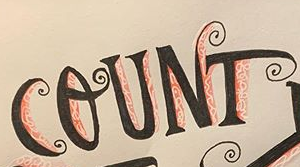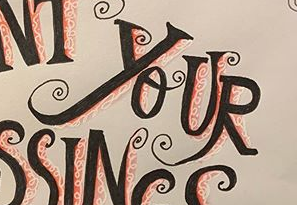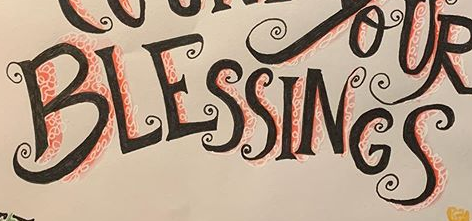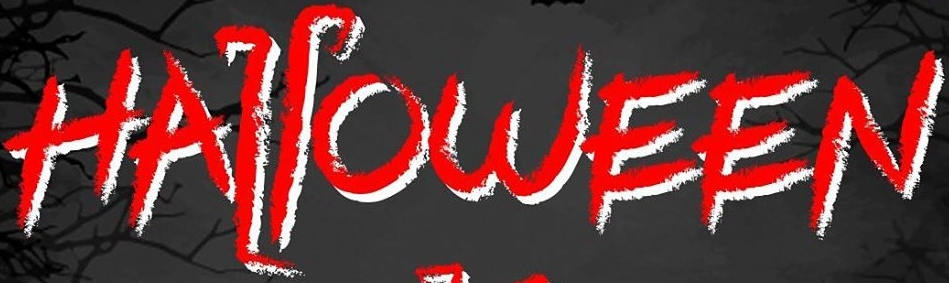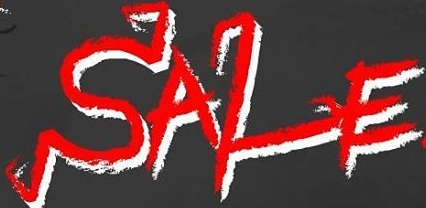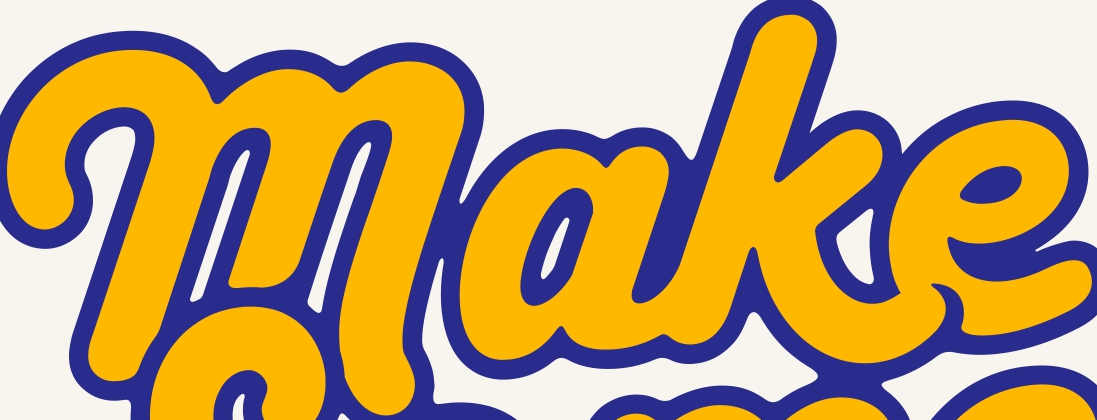What text appears in these images from left to right, separated by a semicolon? COUNT; YOUR; BLESSINGS; HALLOWEEN; SALE; make 